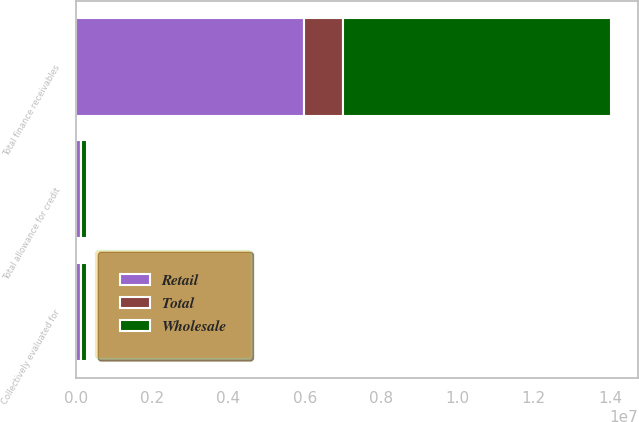<chart> <loc_0><loc_0><loc_500><loc_500><stacked_bar_chart><ecel><fcel>Collectively evaluated for<fcel>Total allowance for credit<fcel>Total finance receivables<nl><fcel>Retail<fcel>139320<fcel>139320<fcel>5.99147e+06<nl><fcel>Total<fcel>7858<fcel>7858<fcel>1.02386e+06<nl><fcel>Wholesale<fcel>147178<fcel>147178<fcel>7.01533e+06<nl></chart> 